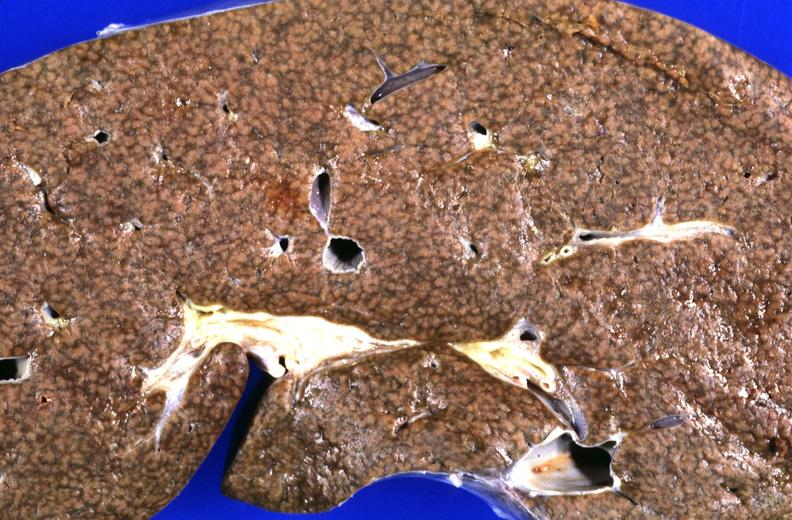does cysticercosis show liver, cirrhosis and iron overload, chronic sickle cell disease with multiple blood transfusions?
Answer the question using a single word or phrase. No 